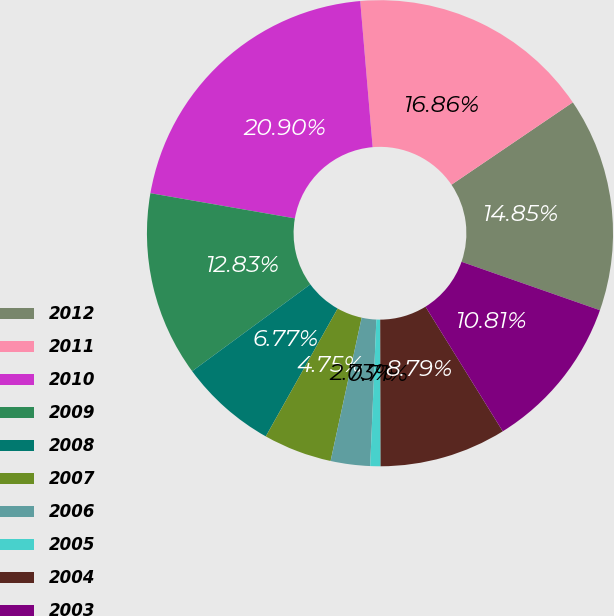Convert chart to OTSL. <chart><loc_0><loc_0><loc_500><loc_500><pie_chart><fcel>2012<fcel>2011<fcel>2010<fcel>2009<fcel>2008<fcel>2007<fcel>2006<fcel>2005<fcel>2004<fcel>2003<nl><fcel>14.85%<fcel>16.86%<fcel>20.9%<fcel>12.83%<fcel>6.77%<fcel>4.75%<fcel>2.73%<fcel>0.71%<fcel>8.79%<fcel>10.81%<nl></chart> 